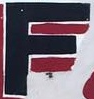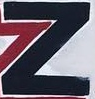What text is displayed in these images sequentially, separated by a semicolon? F; Z 